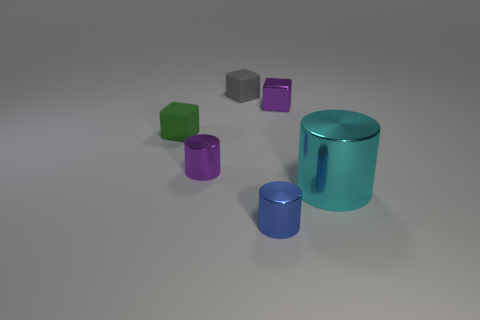Subtract all cyan cylinders. Subtract all brown balls. How many cylinders are left? 2 Subtract all red balls. How many brown cubes are left? 0 Add 4 tiny purples. How many small grays exist? 0 Subtract all gray objects. Subtract all red cylinders. How many objects are left? 5 Add 3 matte things. How many matte things are left? 5 Add 4 brown balls. How many brown balls exist? 4 Add 3 big cyan cylinders. How many objects exist? 9 Subtract all purple blocks. How many blocks are left? 2 Subtract all tiny purple metal cubes. How many cubes are left? 2 Subtract 0 cyan balls. How many objects are left? 6 